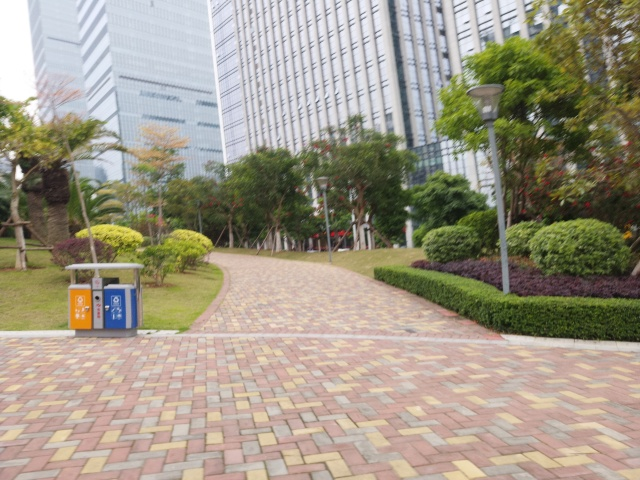What type of location is this image likely taken in? This image appears to be taken in a landscaped urban park situated among high-rise buildings, likely serving as a green space for relaxation and recreation amidst a densely built environment. 